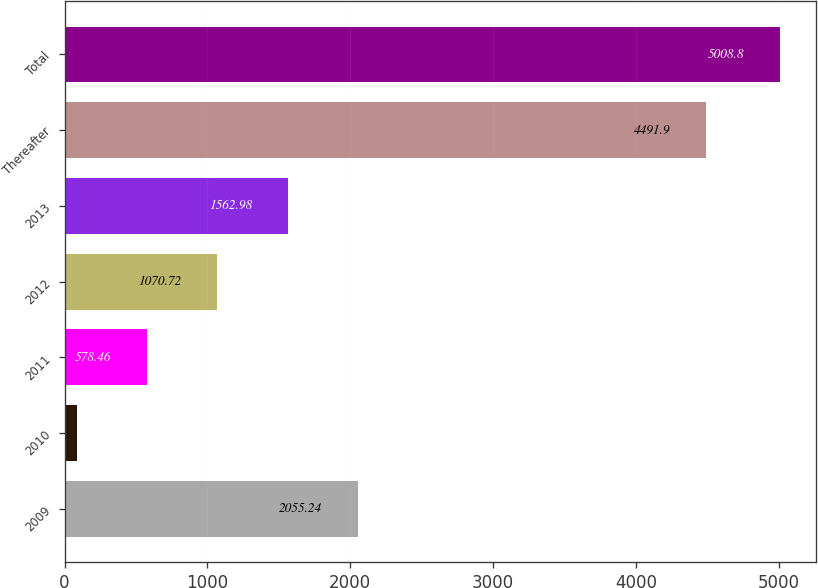<chart> <loc_0><loc_0><loc_500><loc_500><bar_chart><fcel>2009<fcel>2010<fcel>2011<fcel>2012<fcel>2013<fcel>Thereafter<fcel>Total<nl><fcel>2055.24<fcel>86.2<fcel>578.46<fcel>1070.72<fcel>1562.98<fcel>4491.9<fcel>5008.8<nl></chart> 